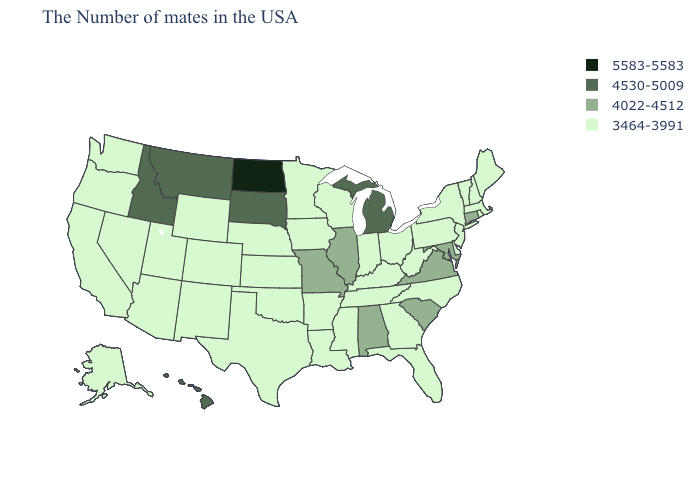Among the states that border West Virginia , which have the lowest value?
Write a very short answer. Pennsylvania, Ohio, Kentucky. Which states have the highest value in the USA?
Give a very brief answer. North Dakota. Does North Dakota have the highest value in the USA?
Be succinct. Yes. Name the states that have a value in the range 4022-4512?
Answer briefly. Connecticut, Maryland, Virginia, South Carolina, Alabama, Illinois, Missouri. Does Pennsylvania have the highest value in the Northeast?
Keep it brief. No. What is the lowest value in states that border Georgia?
Keep it brief. 3464-3991. Which states hav the highest value in the MidWest?
Quick response, please. North Dakota. What is the value of Minnesota?
Give a very brief answer. 3464-3991. Name the states that have a value in the range 4022-4512?
Give a very brief answer. Connecticut, Maryland, Virginia, South Carolina, Alabama, Illinois, Missouri. What is the highest value in the USA?
Give a very brief answer. 5583-5583. Name the states that have a value in the range 4022-4512?
Give a very brief answer. Connecticut, Maryland, Virginia, South Carolina, Alabama, Illinois, Missouri. Name the states that have a value in the range 4022-4512?
Be succinct. Connecticut, Maryland, Virginia, South Carolina, Alabama, Illinois, Missouri. Name the states that have a value in the range 3464-3991?
Give a very brief answer. Maine, Massachusetts, Rhode Island, New Hampshire, Vermont, New York, New Jersey, Delaware, Pennsylvania, North Carolina, West Virginia, Ohio, Florida, Georgia, Kentucky, Indiana, Tennessee, Wisconsin, Mississippi, Louisiana, Arkansas, Minnesota, Iowa, Kansas, Nebraska, Oklahoma, Texas, Wyoming, Colorado, New Mexico, Utah, Arizona, Nevada, California, Washington, Oregon, Alaska. Among the states that border Michigan , which have the highest value?
Write a very short answer. Ohio, Indiana, Wisconsin. Which states have the highest value in the USA?
Write a very short answer. North Dakota. 